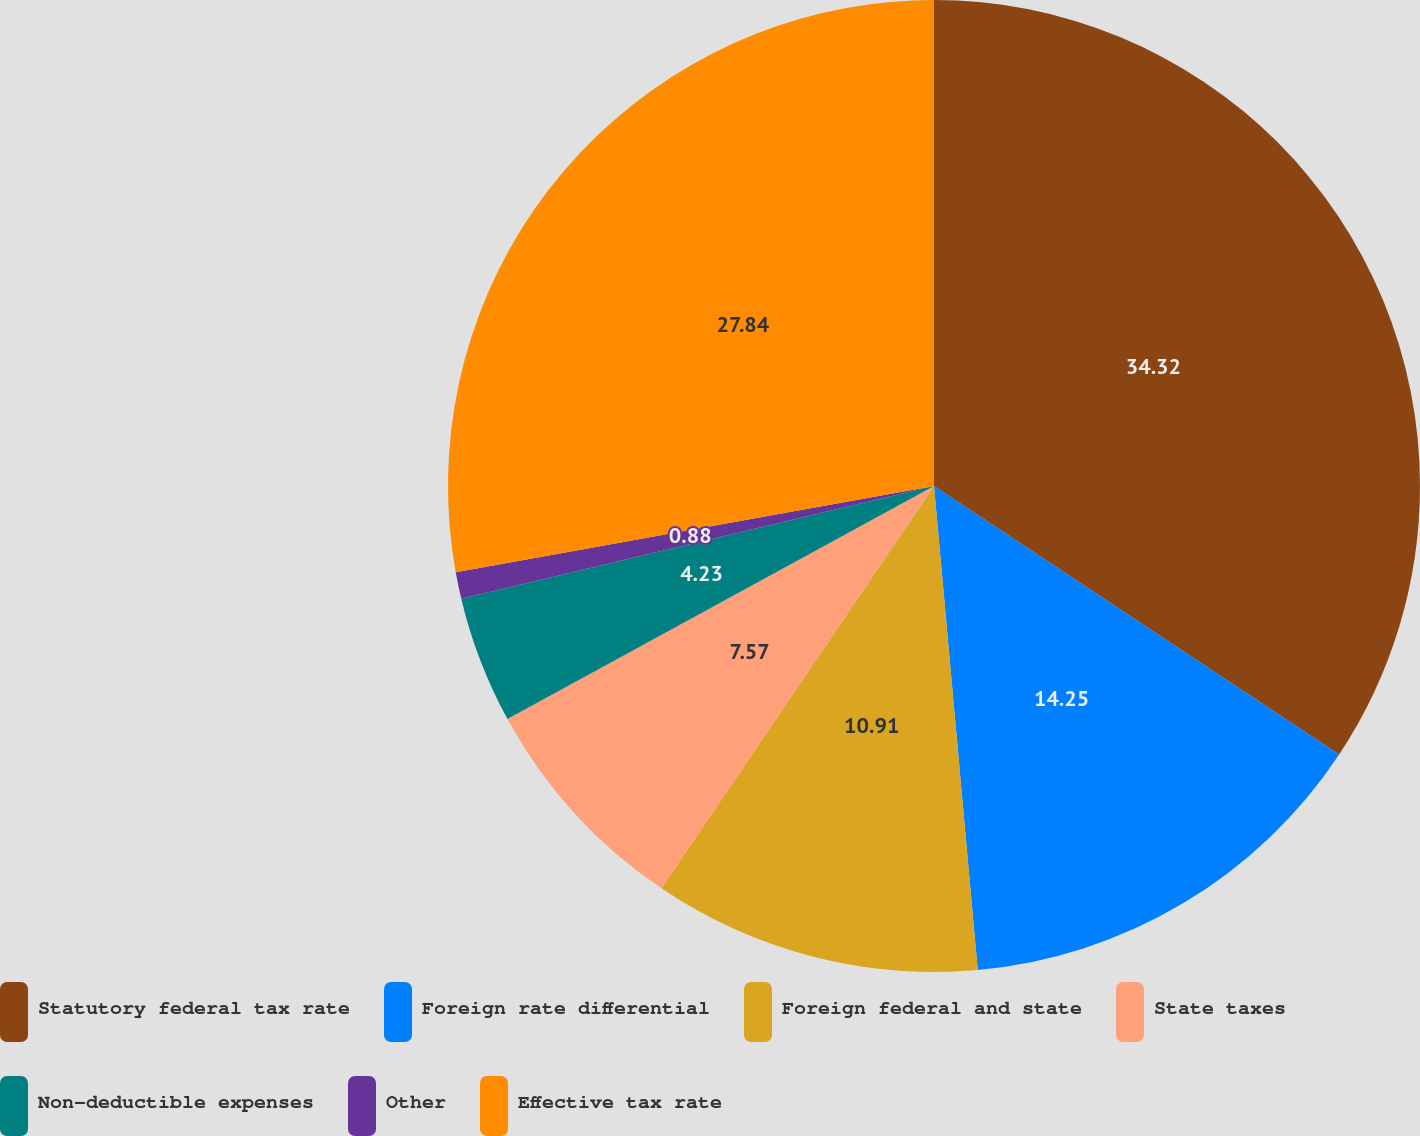Convert chart to OTSL. <chart><loc_0><loc_0><loc_500><loc_500><pie_chart><fcel>Statutory federal tax rate<fcel>Foreign rate differential<fcel>Foreign federal and state<fcel>State taxes<fcel>Non-deductible expenses<fcel>Other<fcel>Effective tax rate<nl><fcel>34.31%<fcel>14.25%<fcel>10.91%<fcel>7.57%<fcel>4.23%<fcel>0.88%<fcel>27.84%<nl></chart> 